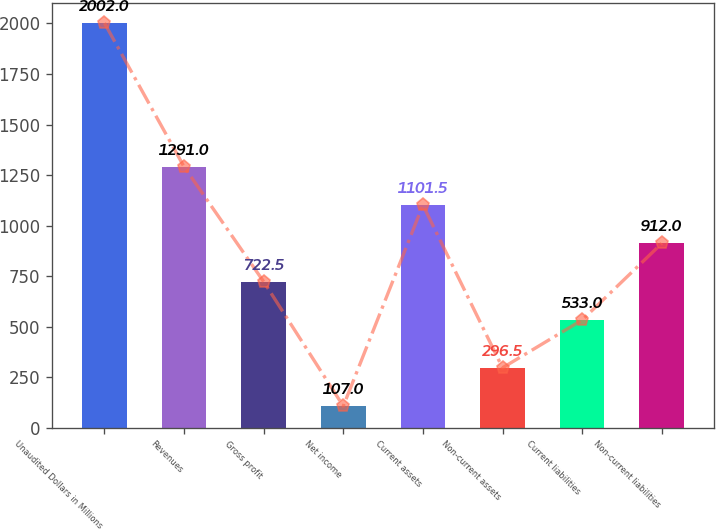<chart> <loc_0><loc_0><loc_500><loc_500><bar_chart><fcel>Unaudited Dollars in Millions<fcel>Revenues<fcel>Gross profit<fcel>Net income<fcel>Current assets<fcel>Non-current assets<fcel>Current liabilities<fcel>Non-current liabilities<nl><fcel>2002<fcel>1291<fcel>722.5<fcel>107<fcel>1101.5<fcel>296.5<fcel>533<fcel>912<nl></chart> 